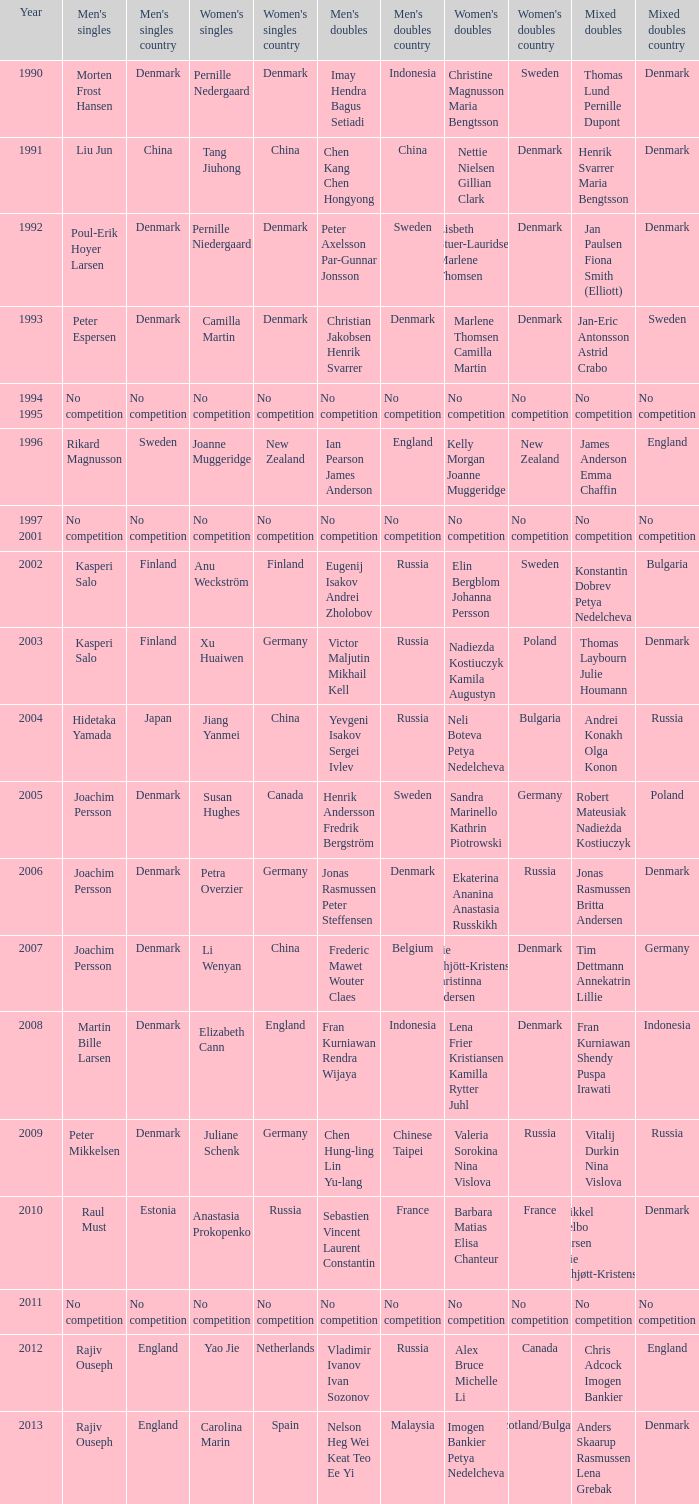In which year did carolina marin secure the women's singles title? 2013.0. 